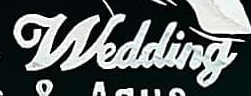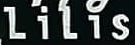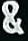What text appears in these images from left to right, separated by a semicolon? Wedding; LiLis; & 